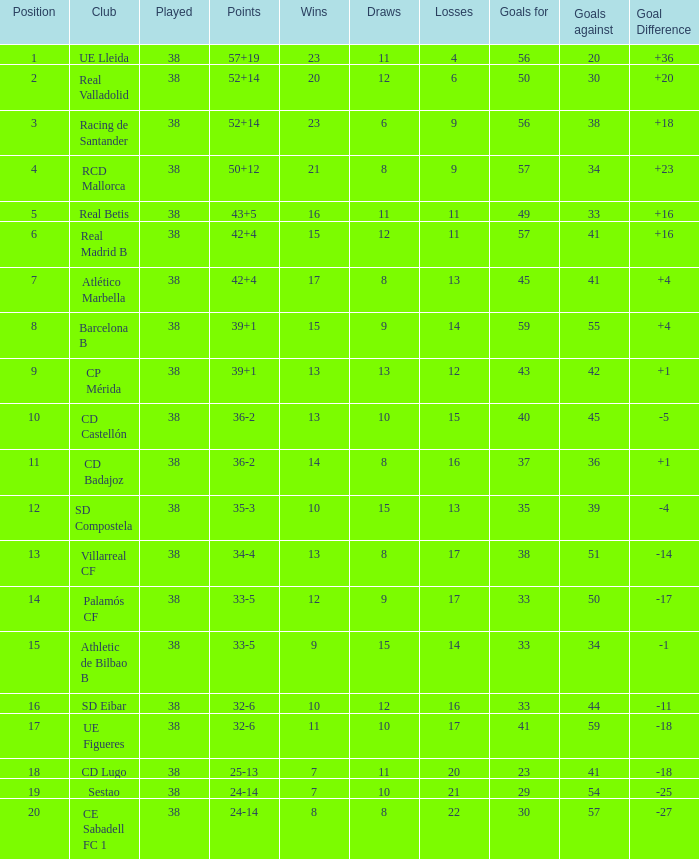For a team placed 7th with over 45 goals, what is the highest count of losses? None. 